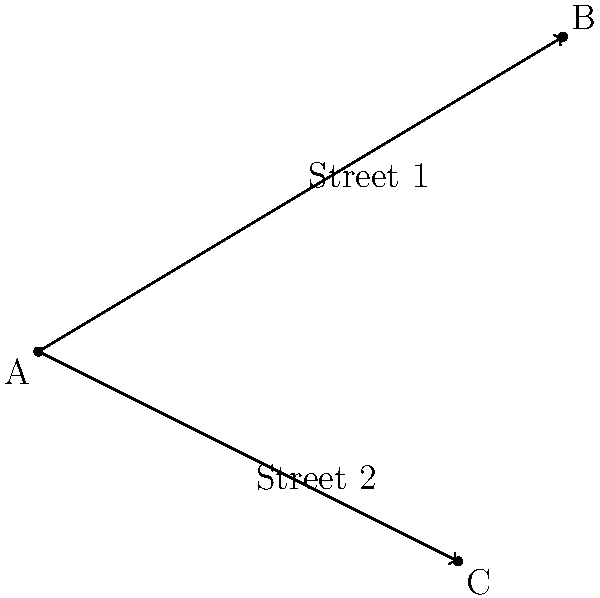In the old town of Divriği, two historic streets intersect at point A. Street 1 runs from point A(0,0) to point B(5,3), while Street 2 runs from point A(0,0) to point C(4,-2). Calculate the angle between these two streets using slope calculations. To find the angle between the two streets, we'll follow these steps:

1. Calculate the slopes of both streets:
   For Street 1 (AB): $m_1 = \frac{y_B - y_A}{x_B - x_A} = \frac{3 - 0}{5 - 0} = \frac{3}{5}$
   For Street 2 (AC): $m_2 = \frac{y_C - y_A}{x_C - x_A} = \frac{-2 - 0}{4 - 0} = -\frac{1}{2}$

2. Use the formula for the angle between two lines:
   $\tan \theta = |\frac{m_1 - m_2}{1 + m_1m_2}|$

3. Substitute the slopes into the formula:
   $\tan \theta = |\frac{\frac{3}{5} - (-\frac{1}{2})}{1 + \frac{3}{5}(-\frac{1}{2})}| = |\frac{\frac{3}{5} + \frac{1}{2}}{1 - \frac{3}{10}}|$

4. Simplify:
   $\tan \theta = |\frac{\frac{6}{10} + \frac{5}{10}}{\frac{10}{10} - \frac{3}{10}}| = |\frac{\frac{11}{10}}{\frac{7}{10}}| = \frac{11}{7}$

5. Calculate the angle using inverse tangent:
   $\theta = \arctan(\frac{11}{7})$

6. Convert to degrees:
   $\theta \approx 57.54°$
Answer: $57.54°$ 